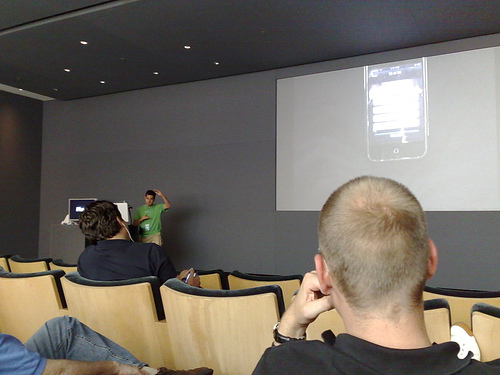<image>
Is there a screen on the wall? No. The screen is not positioned on the wall. They may be near each other, but the screen is not supported by or resting on top of the wall. 